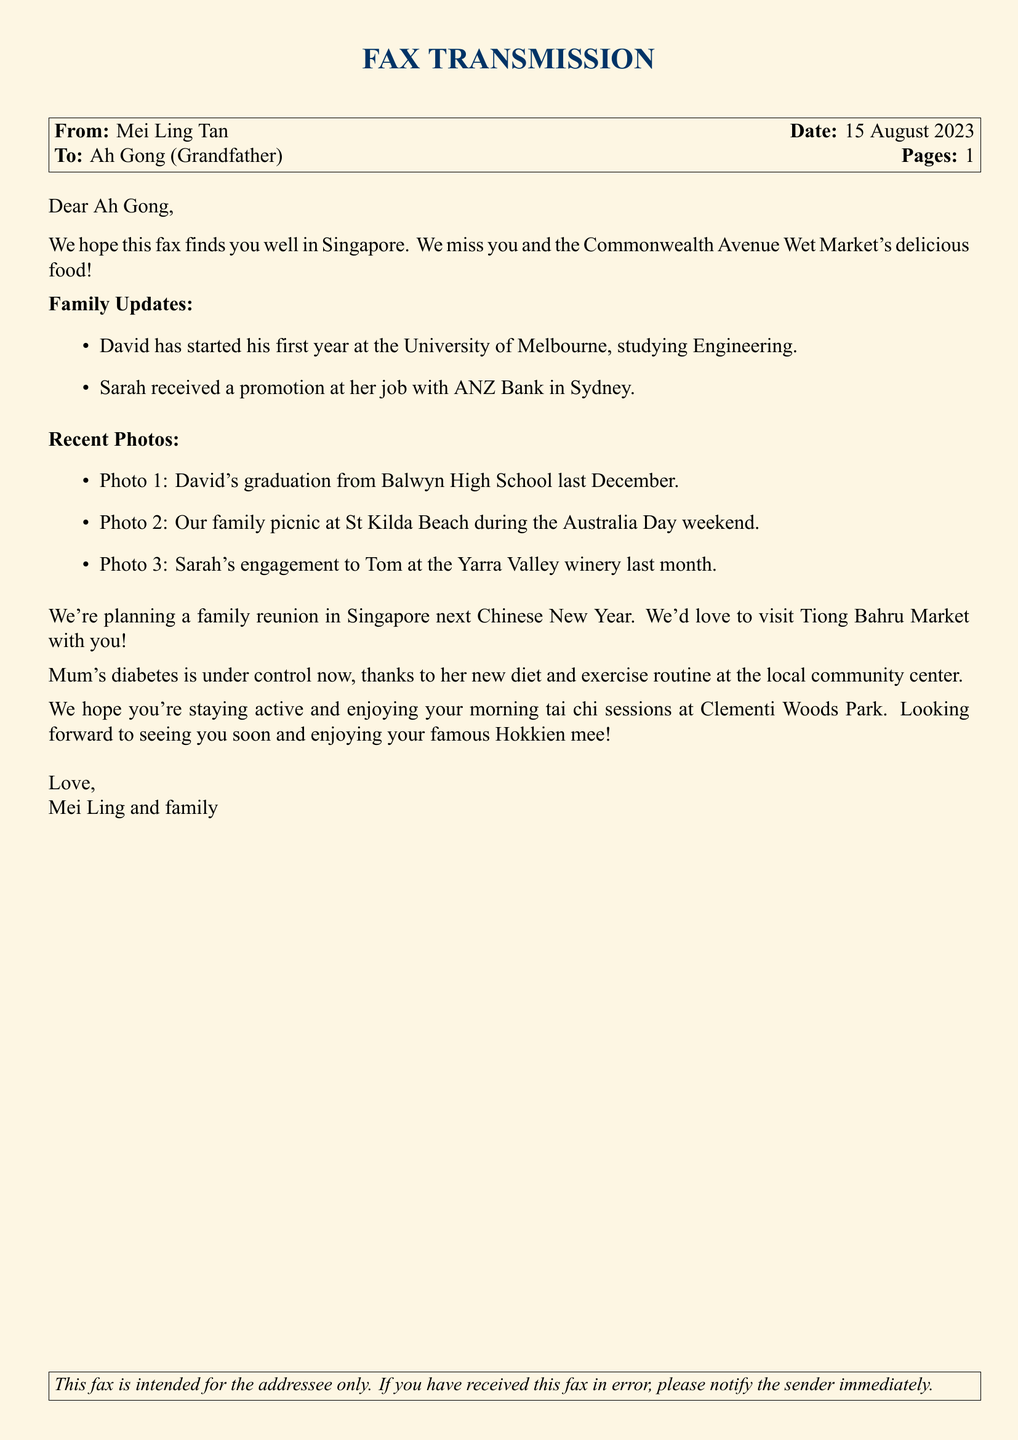what is the name of the sender? The sender of the fax is mentioned at the top of the document as Mei Ling Tan.
Answer: Mei Ling Tan what is the date of the fax? The date is given in the header section of the document as 15 August 2023.
Answer: 15 August 2023 who is receiving the fax? The recipient's name is listed in the address as Ah Gong (Grandfather).
Answer: Ah Gong (Grandfather) how many families are mentioned in the updates? The family updates section refers to two family members, David and Sarah.
Answer: Two what is David studying at university? The document states that David is studying Engineering at the University of Melbourne.
Answer: Engineering where did the family have a picnic? The document mentions that the family picnic took place at St Kilda Beach.
Answer: St Kilda Beach what event is planned for next Chinese New Year? The document indicates that a family reunion is planned for next Chinese New Year.
Answer: Family reunion how is Mum's health? The document states that Mum's diabetes is under control now.
Answer: Under control what activity does Ah Gong participate in the mornings? The document mentions that Ah Gong enjoys morning tai chi sessions.
Answer: Tai chi sessions what type of market do they want to visit in Singapore? The document expresses a desire to visit Tiong Bahru Market.
Answer: Tiong Bahru Market 